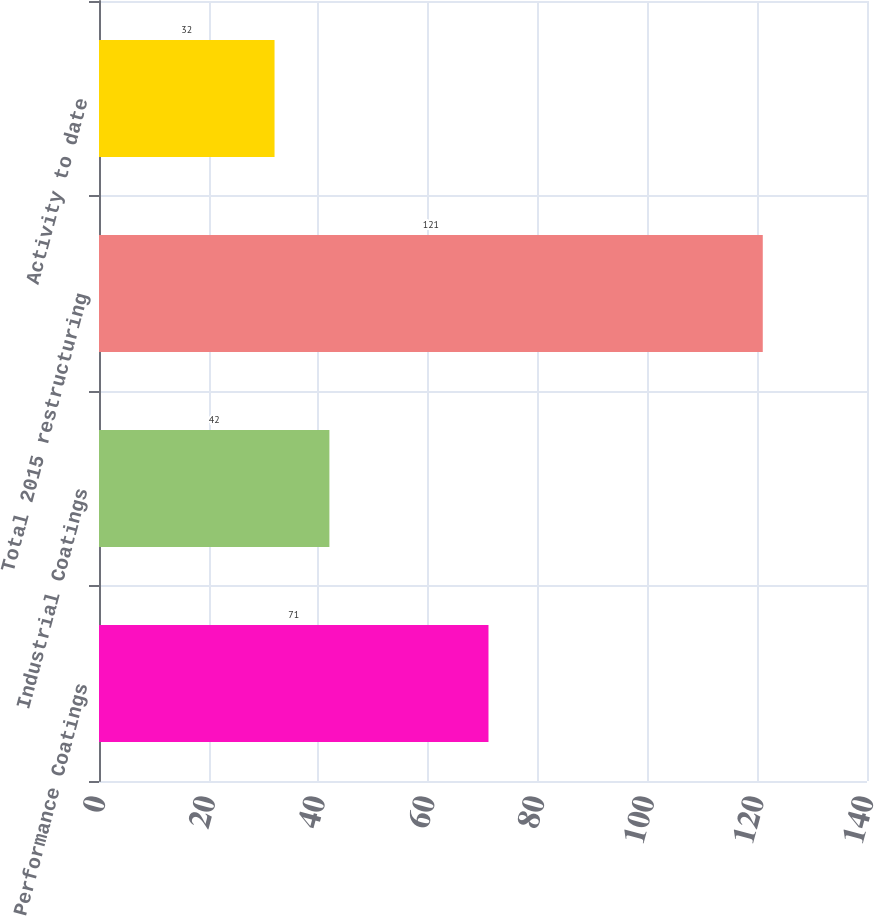Convert chart. <chart><loc_0><loc_0><loc_500><loc_500><bar_chart><fcel>Performance Coatings<fcel>Industrial Coatings<fcel>Total 2015 restructuring<fcel>Activity to date<nl><fcel>71<fcel>42<fcel>121<fcel>32<nl></chart> 